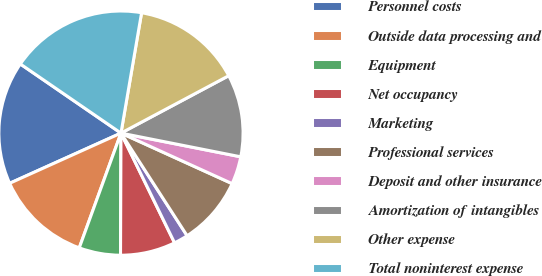Convert chart to OTSL. <chart><loc_0><loc_0><loc_500><loc_500><pie_chart><fcel>Personnel costs<fcel>Outside data processing and<fcel>Equipment<fcel>Net occupancy<fcel>Marketing<fcel>Professional services<fcel>Deposit and other insurance<fcel>Amortization of intangibles<fcel>Other expense<fcel>Total noninterest expense<nl><fcel>16.32%<fcel>12.71%<fcel>5.49%<fcel>7.29%<fcel>1.88%<fcel>9.1%<fcel>3.68%<fcel>10.9%<fcel>14.51%<fcel>18.12%<nl></chart> 